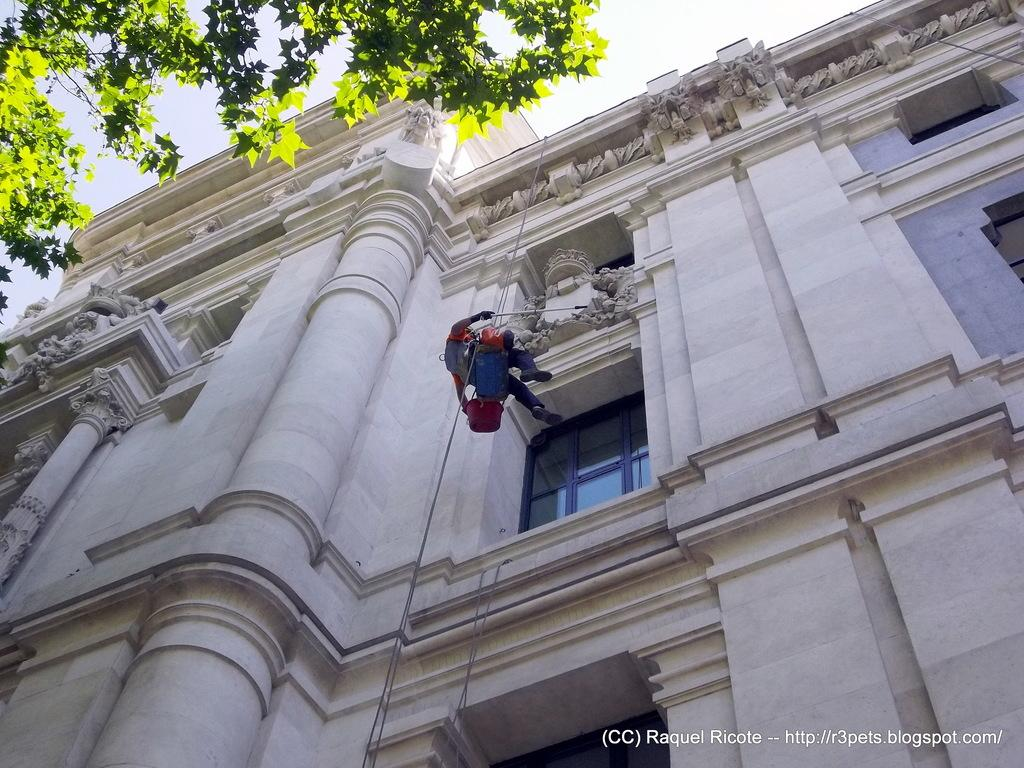What is the main structure in the image? There is a building in the image. What feature can be seen on the building? The building has windows. What is a person doing in relation to the building? A person is climbing on the building. What is located at the top of the building? There is a tree at the top of the building. What can be seen in the background of the image? The sky is visible in the image. When was the image taken? The image was taken during the day. How many sticks are being used by the person climbing the building? There is no mention of sticks being used by the person climbing the building in the image. 